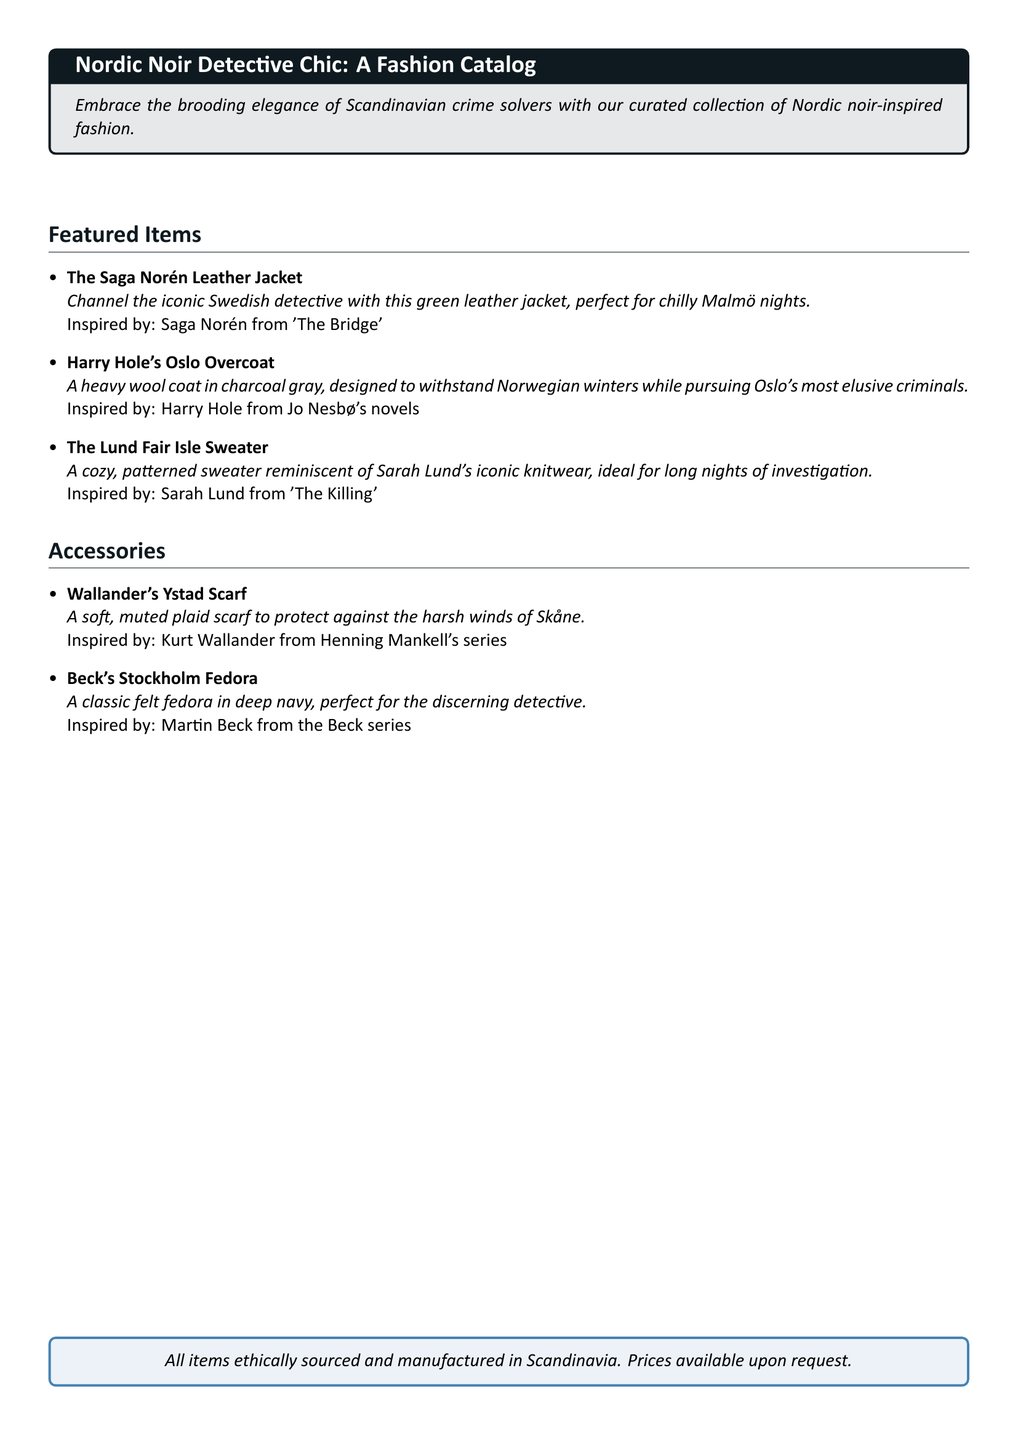what is the name of the jacket inspired by Saga Norén? The jacket named after Saga Norén is listed as "The Saga Norén Leather Jacket."
Answer: The Saga Norén Leather Jacket which detective is associated with the charcoal gray overcoat? The charcoal gray overcoat is inspired by Harry Hole from Jo Nesbø's novels.
Answer: Harry Hole what color is Wallander's scarf? Wallander's scarf is described as soft and muted plaid, suggesting shades that are typically softer, but the exact color isn't specified in the document.
Answer: Muted plaid how many items are listed in the Featured Items section? There are three items mentioned in the Featured Items section of the catalog.
Answer: Three what type of hat is inspired by Martin Beck? The hat inspired by Martin Beck is a felt fedora.
Answer: Fedora what is the main material of Harry Hole's overcoat? The main material of Harry Hole's overcoat is heavy wool.
Answer: Wool which character’s style is the Lund Fair Isle Sweater based on? The Lund Fair Isle Sweater is based on the style of Sarah Lund.
Answer: Sarah Lund are the items ethically sourced? Yes, it is stated that all items are ethically sourced and manufactured in Scandinavia.
Answer: Yes 